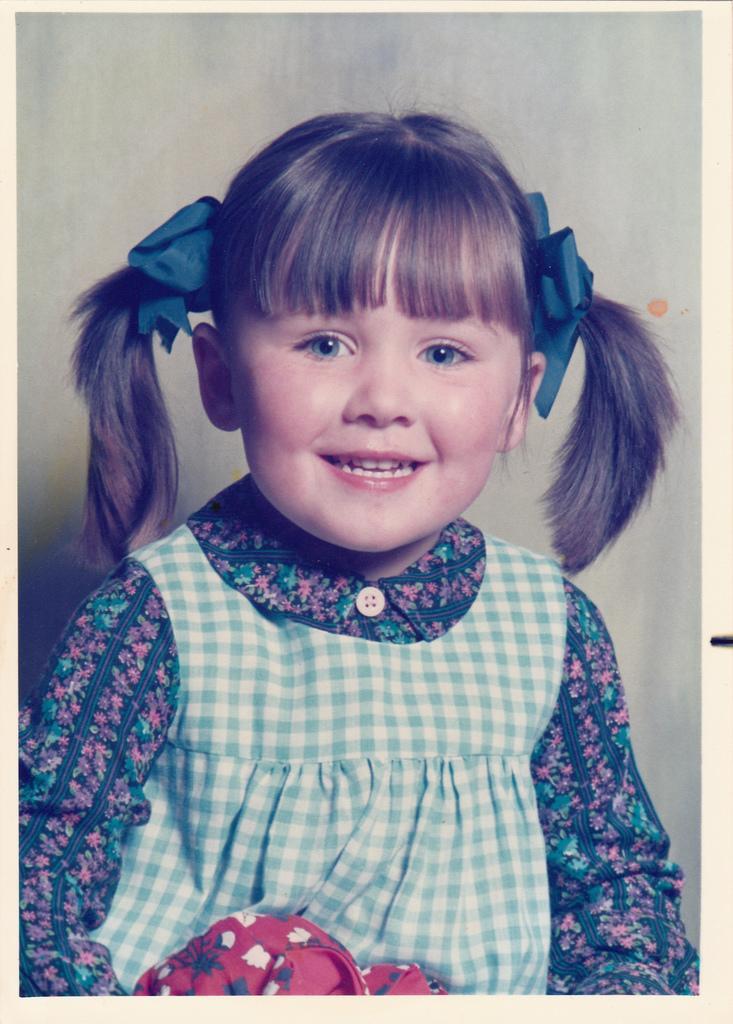Could you give a brief overview of what you see in this image? Here we can see a girl and she is smiling. 